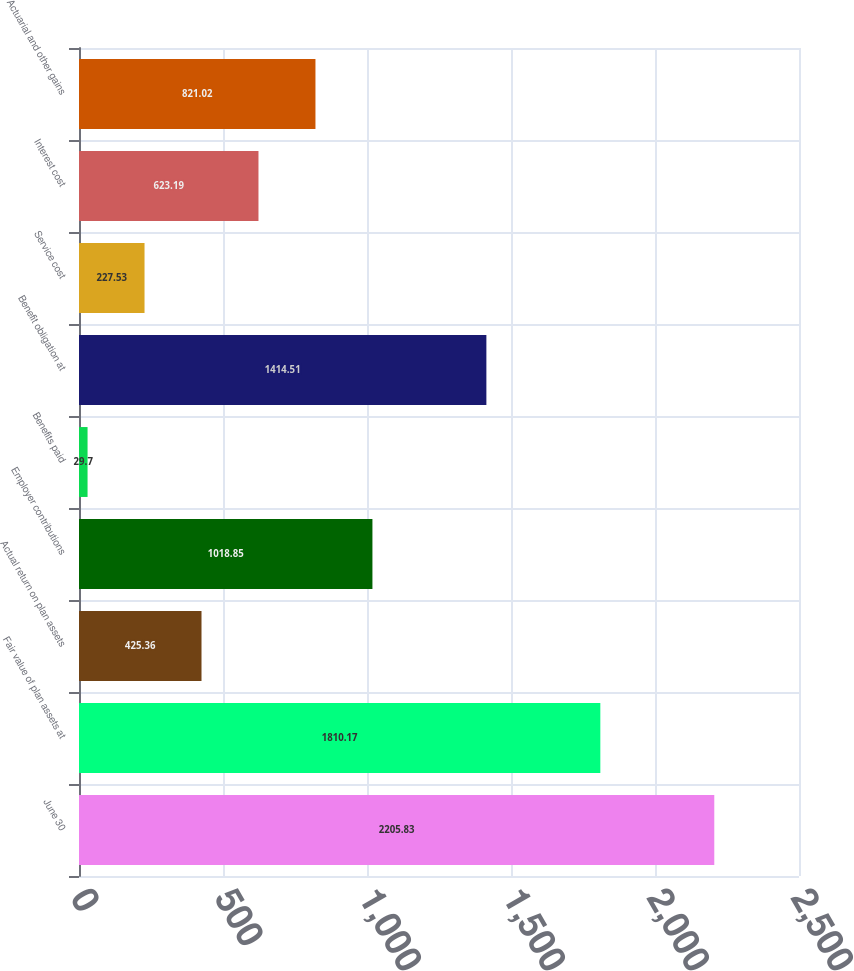Convert chart to OTSL. <chart><loc_0><loc_0><loc_500><loc_500><bar_chart><fcel>June 30<fcel>Fair value of plan assets at<fcel>Actual return on plan assets<fcel>Employer contributions<fcel>Benefits paid<fcel>Benefit obligation at<fcel>Service cost<fcel>Interest cost<fcel>Actuarial and other gains<nl><fcel>2205.83<fcel>1810.17<fcel>425.36<fcel>1018.85<fcel>29.7<fcel>1414.51<fcel>227.53<fcel>623.19<fcel>821.02<nl></chart> 